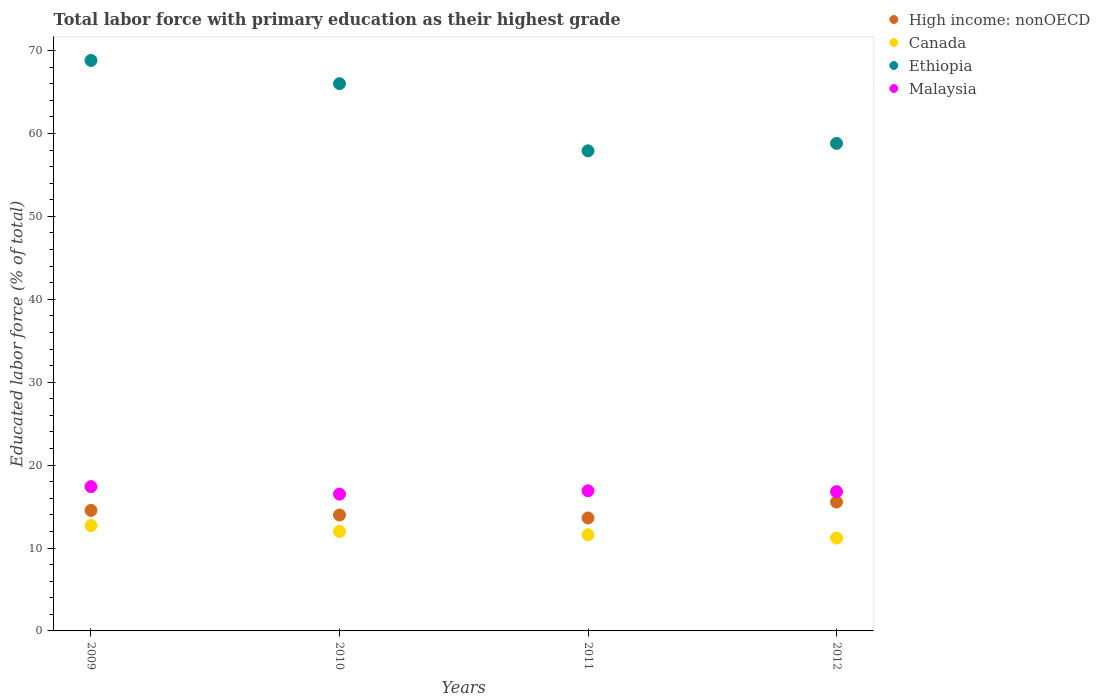How many different coloured dotlines are there?
Offer a terse response. 4. What is the percentage of total labor force with primary education in Ethiopia in 2009?
Your answer should be compact. 68.8. Across all years, what is the maximum percentage of total labor force with primary education in High income: nonOECD?
Provide a short and direct response. 15.55. What is the total percentage of total labor force with primary education in Malaysia in the graph?
Ensure brevity in your answer.  67.6. What is the difference between the percentage of total labor force with primary education in High income: nonOECD in 2009 and that in 2011?
Offer a terse response. 0.91. What is the difference between the percentage of total labor force with primary education in Malaysia in 2012 and the percentage of total labor force with primary education in Canada in 2010?
Make the answer very short. 4.8. What is the average percentage of total labor force with primary education in High income: nonOECD per year?
Offer a terse response. 14.42. In the year 2012, what is the difference between the percentage of total labor force with primary education in Malaysia and percentage of total labor force with primary education in Canada?
Make the answer very short. 5.6. In how many years, is the percentage of total labor force with primary education in Malaysia greater than 36 %?
Your response must be concise. 0. What is the ratio of the percentage of total labor force with primary education in Canada in 2009 to that in 2011?
Make the answer very short. 1.09. Is the percentage of total labor force with primary education in High income: nonOECD in 2009 less than that in 2012?
Your answer should be very brief. Yes. Is the difference between the percentage of total labor force with primary education in Malaysia in 2009 and 2011 greater than the difference between the percentage of total labor force with primary education in Canada in 2009 and 2011?
Keep it short and to the point. No. What is the difference between the highest and the second highest percentage of total labor force with primary education in Ethiopia?
Offer a terse response. 2.8. What is the difference between the highest and the lowest percentage of total labor force with primary education in Malaysia?
Offer a terse response. 0.9. Is the sum of the percentage of total labor force with primary education in Malaysia in 2011 and 2012 greater than the maximum percentage of total labor force with primary education in Canada across all years?
Provide a short and direct response. Yes. Is it the case that in every year, the sum of the percentage of total labor force with primary education in Malaysia and percentage of total labor force with primary education in Canada  is greater than the sum of percentage of total labor force with primary education in High income: nonOECD and percentage of total labor force with primary education in Ethiopia?
Make the answer very short. Yes. Is it the case that in every year, the sum of the percentage of total labor force with primary education in Canada and percentage of total labor force with primary education in Ethiopia  is greater than the percentage of total labor force with primary education in High income: nonOECD?
Keep it short and to the point. Yes. Does the percentage of total labor force with primary education in Canada monotonically increase over the years?
Provide a short and direct response. No. Is the percentage of total labor force with primary education in Canada strictly greater than the percentage of total labor force with primary education in High income: nonOECD over the years?
Make the answer very short. No. How many years are there in the graph?
Provide a succinct answer. 4. What is the difference between two consecutive major ticks on the Y-axis?
Offer a terse response. 10. Are the values on the major ticks of Y-axis written in scientific E-notation?
Offer a very short reply. No. Does the graph contain any zero values?
Give a very brief answer. No. Does the graph contain grids?
Your answer should be very brief. No. Where does the legend appear in the graph?
Provide a succinct answer. Top right. How many legend labels are there?
Provide a succinct answer. 4. How are the legend labels stacked?
Ensure brevity in your answer.  Vertical. What is the title of the graph?
Provide a short and direct response. Total labor force with primary education as their highest grade. What is the label or title of the X-axis?
Provide a succinct answer. Years. What is the label or title of the Y-axis?
Provide a succinct answer. Educated labor force (% of total). What is the Educated labor force (% of total) in High income: nonOECD in 2009?
Provide a short and direct response. 14.54. What is the Educated labor force (% of total) in Canada in 2009?
Offer a terse response. 12.7. What is the Educated labor force (% of total) of Ethiopia in 2009?
Your response must be concise. 68.8. What is the Educated labor force (% of total) in Malaysia in 2009?
Provide a short and direct response. 17.4. What is the Educated labor force (% of total) of High income: nonOECD in 2010?
Provide a short and direct response. 13.98. What is the Educated labor force (% of total) in Malaysia in 2010?
Your answer should be compact. 16.5. What is the Educated labor force (% of total) in High income: nonOECD in 2011?
Ensure brevity in your answer.  13.62. What is the Educated labor force (% of total) of Canada in 2011?
Your answer should be very brief. 11.6. What is the Educated labor force (% of total) of Ethiopia in 2011?
Your answer should be very brief. 57.9. What is the Educated labor force (% of total) in Malaysia in 2011?
Provide a succinct answer. 16.9. What is the Educated labor force (% of total) in High income: nonOECD in 2012?
Provide a succinct answer. 15.55. What is the Educated labor force (% of total) in Canada in 2012?
Provide a short and direct response. 11.2. What is the Educated labor force (% of total) of Ethiopia in 2012?
Offer a very short reply. 58.8. What is the Educated labor force (% of total) in Malaysia in 2012?
Your answer should be compact. 16.8. Across all years, what is the maximum Educated labor force (% of total) of High income: nonOECD?
Provide a succinct answer. 15.55. Across all years, what is the maximum Educated labor force (% of total) of Canada?
Keep it short and to the point. 12.7. Across all years, what is the maximum Educated labor force (% of total) in Ethiopia?
Offer a terse response. 68.8. Across all years, what is the maximum Educated labor force (% of total) of Malaysia?
Provide a succinct answer. 17.4. Across all years, what is the minimum Educated labor force (% of total) of High income: nonOECD?
Your answer should be compact. 13.62. Across all years, what is the minimum Educated labor force (% of total) in Canada?
Provide a short and direct response. 11.2. Across all years, what is the minimum Educated labor force (% of total) in Ethiopia?
Your answer should be very brief. 57.9. Across all years, what is the minimum Educated labor force (% of total) of Malaysia?
Offer a very short reply. 16.5. What is the total Educated labor force (% of total) of High income: nonOECD in the graph?
Offer a terse response. 57.68. What is the total Educated labor force (% of total) in Canada in the graph?
Provide a succinct answer. 47.5. What is the total Educated labor force (% of total) in Ethiopia in the graph?
Give a very brief answer. 251.5. What is the total Educated labor force (% of total) of Malaysia in the graph?
Offer a very short reply. 67.6. What is the difference between the Educated labor force (% of total) in High income: nonOECD in 2009 and that in 2010?
Your response must be concise. 0.56. What is the difference between the Educated labor force (% of total) in Canada in 2009 and that in 2010?
Provide a succinct answer. 0.7. What is the difference between the Educated labor force (% of total) in Malaysia in 2009 and that in 2010?
Offer a terse response. 0.9. What is the difference between the Educated labor force (% of total) in High income: nonOECD in 2009 and that in 2011?
Give a very brief answer. 0.91. What is the difference between the Educated labor force (% of total) in High income: nonOECD in 2009 and that in 2012?
Keep it short and to the point. -1.01. What is the difference between the Educated labor force (% of total) in Canada in 2009 and that in 2012?
Your answer should be compact. 1.5. What is the difference between the Educated labor force (% of total) in Ethiopia in 2009 and that in 2012?
Offer a very short reply. 10. What is the difference between the Educated labor force (% of total) in Malaysia in 2009 and that in 2012?
Give a very brief answer. 0.6. What is the difference between the Educated labor force (% of total) of High income: nonOECD in 2010 and that in 2011?
Give a very brief answer. 0.35. What is the difference between the Educated labor force (% of total) in Canada in 2010 and that in 2011?
Make the answer very short. 0.4. What is the difference between the Educated labor force (% of total) of Malaysia in 2010 and that in 2011?
Your answer should be compact. -0.4. What is the difference between the Educated labor force (% of total) of High income: nonOECD in 2010 and that in 2012?
Keep it short and to the point. -1.57. What is the difference between the Educated labor force (% of total) in Canada in 2010 and that in 2012?
Offer a very short reply. 0.8. What is the difference between the Educated labor force (% of total) in Malaysia in 2010 and that in 2012?
Give a very brief answer. -0.3. What is the difference between the Educated labor force (% of total) in High income: nonOECD in 2011 and that in 2012?
Your answer should be compact. -1.92. What is the difference between the Educated labor force (% of total) of High income: nonOECD in 2009 and the Educated labor force (% of total) of Canada in 2010?
Give a very brief answer. 2.54. What is the difference between the Educated labor force (% of total) of High income: nonOECD in 2009 and the Educated labor force (% of total) of Ethiopia in 2010?
Your answer should be compact. -51.46. What is the difference between the Educated labor force (% of total) of High income: nonOECD in 2009 and the Educated labor force (% of total) of Malaysia in 2010?
Provide a succinct answer. -1.96. What is the difference between the Educated labor force (% of total) in Canada in 2009 and the Educated labor force (% of total) in Ethiopia in 2010?
Your response must be concise. -53.3. What is the difference between the Educated labor force (% of total) of Ethiopia in 2009 and the Educated labor force (% of total) of Malaysia in 2010?
Keep it short and to the point. 52.3. What is the difference between the Educated labor force (% of total) of High income: nonOECD in 2009 and the Educated labor force (% of total) of Canada in 2011?
Offer a very short reply. 2.94. What is the difference between the Educated labor force (% of total) of High income: nonOECD in 2009 and the Educated labor force (% of total) of Ethiopia in 2011?
Provide a short and direct response. -43.36. What is the difference between the Educated labor force (% of total) in High income: nonOECD in 2009 and the Educated labor force (% of total) in Malaysia in 2011?
Provide a succinct answer. -2.36. What is the difference between the Educated labor force (% of total) in Canada in 2009 and the Educated labor force (% of total) in Ethiopia in 2011?
Keep it short and to the point. -45.2. What is the difference between the Educated labor force (% of total) of Ethiopia in 2009 and the Educated labor force (% of total) of Malaysia in 2011?
Your answer should be very brief. 51.9. What is the difference between the Educated labor force (% of total) of High income: nonOECD in 2009 and the Educated labor force (% of total) of Canada in 2012?
Keep it short and to the point. 3.34. What is the difference between the Educated labor force (% of total) of High income: nonOECD in 2009 and the Educated labor force (% of total) of Ethiopia in 2012?
Your answer should be compact. -44.26. What is the difference between the Educated labor force (% of total) in High income: nonOECD in 2009 and the Educated labor force (% of total) in Malaysia in 2012?
Ensure brevity in your answer.  -2.26. What is the difference between the Educated labor force (% of total) in Canada in 2009 and the Educated labor force (% of total) in Ethiopia in 2012?
Give a very brief answer. -46.1. What is the difference between the Educated labor force (% of total) in High income: nonOECD in 2010 and the Educated labor force (% of total) in Canada in 2011?
Your response must be concise. 2.38. What is the difference between the Educated labor force (% of total) of High income: nonOECD in 2010 and the Educated labor force (% of total) of Ethiopia in 2011?
Your answer should be very brief. -43.92. What is the difference between the Educated labor force (% of total) of High income: nonOECD in 2010 and the Educated labor force (% of total) of Malaysia in 2011?
Your response must be concise. -2.92. What is the difference between the Educated labor force (% of total) of Canada in 2010 and the Educated labor force (% of total) of Ethiopia in 2011?
Make the answer very short. -45.9. What is the difference between the Educated labor force (% of total) in Ethiopia in 2010 and the Educated labor force (% of total) in Malaysia in 2011?
Your answer should be compact. 49.1. What is the difference between the Educated labor force (% of total) of High income: nonOECD in 2010 and the Educated labor force (% of total) of Canada in 2012?
Ensure brevity in your answer.  2.78. What is the difference between the Educated labor force (% of total) of High income: nonOECD in 2010 and the Educated labor force (% of total) of Ethiopia in 2012?
Your response must be concise. -44.82. What is the difference between the Educated labor force (% of total) of High income: nonOECD in 2010 and the Educated labor force (% of total) of Malaysia in 2012?
Provide a succinct answer. -2.82. What is the difference between the Educated labor force (% of total) in Canada in 2010 and the Educated labor force (% of total) in Ethiopia in 2012?
Your answer should be very brief. -46.8. What is the difference between the Educated labor force (% of total) of Canada in 2010 and the Educated labor force (% of total) of Malaysia in 2012?
Provide a succinct answer. -4.8. What is the difference between the Educated labor force (% of total) in Ethiopia in 2010 and the Educated labor force (% of total) in Malaysia in 2012?
Your answer should be very brief. 49.2. What is the difference between the Educated labor force (% of total) in High income: nonOECD in 2011 and the Educated labor force (% of total) in Canada in 2012?
Keep it short and to the point. 2.42. What is the difference between the Educated labor force (% of total) of High income: nonOECD in 2011 and the Educated labor force (% of total) of Ethiopia in 2012?
Ensure brevity in your answer.  -45.18. What is the difference between the Educated labor force (% of total) of High income: nonOECD in 2011 and the Educated labor force (% of total) of Malaysia in 2012?
Keep it short and to the point. -3.18. What is the difference between the Educated labor force (% of total) in Canada in 2011 and the Educated labor force (% of total) in Ethiopia in 2012?
Your answer should be compact. -47.2. What is the difference between the Educated labor force (% of total) in Ethiopia in 2011 and the Educated labor force (% of total) in Malaysia in 2012?
Give a very brief answer. 41.1. What is the average Educated labor force (% of total) in High income: nonOECD per year?
Make the answer very short. 14.42. What is the average Educated labor force (% of total) in Canada per year?
Give a very brief answer. 11.88. What is the average Educated labor force (% of total) in Ethiopia per year?
Ensure brevity in your answer.  62.88. In the year 2009, what is the difference between the Educated labor force (% of total) of High income: nonOECD and Educated labor force (% of total) of Canada?
Provide a short and direct response. 1.84. In the year 2009, what is the difference between the Educated labor force (% of total) of High income: nonOECD and Educated labor force (% of total) of Ethiopia?
Offer a very short reply. -54.26. In the year 2009, what is the difference between the Educated labor force (% of total) of High income: nonOECD and Educated labor force (% of total) of Malaysia?
Offer a terse response. -2.86. In the year 2009, what is the difference between the Educated labor force (% of total) of Canada and Educated labor force (% of total) of Ethiopia?
Provide a succinct answer. -56.1. In the year 2009, what is the difference between the Educated labor force (% of total) in Canada and Educated labor force (% of total) in Malaysia?
Provide a succinct answer. -4.7. In the year 2009, what is the difference between the Educated labor force (% of total) in Ethiopia and Educated labor force (% of total) in Malaysia?
Make the answer very short. 51.4. In the year 2010, what is the difference between the Educated labor force (% of total) of High income: nonOECD and Educated labor force (% of total) of Canada?
Make the answer very short. 1.98. In the year 2010, what is the difference between the Educated labor force (% of total) of High income: nonOECD and Educated labor force (% of total) of Ethiopia?
Your answer should be compact. -52.02. In the year 2010, what is the difference between the Educated labor force (% of total) of High income: nonOECD and Educated labor force (% of total) of Malaysia?
Ensure brevity in your answer.  -2.52. In the year 2010, what is the difference between the Educated labor force (% of total) of Canada and Educated labor force (% of total) of Ethiopia?
Your answer should be compact. -54. In the year 2010, what is the difference between the Educated labor force (% of total) in Ethiopia and Educated labor force (% of total) in Malaysia?
Give a very brief answer. 49.5. In the year 2011, what is the difference between the Educated labor force (% of total) of High income: nonOECD and Educated labor force (% of total) of Canada?
Your answer should be very brief. 2.02. In the year 2011, what is the difference between the Educated labor force (% of total) of High income: nonOECD and Educated labor force (% of total) of Ethiopia?
Give a very brief answer. -44.28. In the year 2011, what is the difference between the Educated labor force (% of total) in High income: nonOECD and Educated labor force (% of total) in Malaysia?
Make the answer very short. -3.28. In the year 2011, what is the difference between the Educated labor force (% of total) in Canada and Educated labor force (% of total) in Ethiopia?
Provide a succinct answer. -46.3. In the year 2011, what is the difference between the Educated labor force (% of total) in Canada and Educated labor force (% of total) in Malaysia?
Your answer should be compact. -5.3. In the year 2012, what is the difference between the Educated labor force (% of total) in High income: nonOECD and Educated labor force (% of total) in Canada?
Your response must be concise. 4.35. In the year 2012, what is the difference between the Educated labor force (% of total) in High income: nonOECD and Educated labor force (% of total) in Ethiopia?
Provide a short and direct response. -43.25. In the year 2012, what is the difference between the Educated labor force (% of total) of High income: nonOECD and Educated labor force (% of total) of Malaysia?
Your answer should be very brief. -1.25. In the year 2012, what is the difference between the Educated labor force (% of total) of Canada and Educated labor force (% of total) of Ethiopia?
Make the answer very short. -47.6. In the year 2012, what is the difference between the Educated labor force (% of total) in Canada and Educated labor force (% of total) in Malaysia?
Offer a very short reply. -5.6. What is the ratio of the Educated labor force (% of total) in High income: nonOECD in 2009 to that in 2010?
Offer a terse response. 1.04. What is the ratio of the Educated labor force (% of total) in Canada in 2009 to that in 2010?
Provide a short and direct response. 1.06. What is the ratio of the Educated labor force (% of total) of Ethiopia in 2009 to that in 2010?
Offer a terse response. 1.04. What is the ratio of the Educated labor force (% of total) of Malaysia in 2009 to that in 2010?
Keep it short and to the point. 1.05. What is the ratio of the Educated labor force (% of total) of High income: nonOECD in 2009 to that in 2011?
Make the answer very short. 1.07. What is the ratio of the Educated labor force (% of total) in Canada in 2009 to that in 2011?
Ensure brevity in your answer.  1.09. What is the ratio of the Educated labor force (% of total) in Ethiopia in 2009 to that in 2011?
Give a very brief answer. 1.19. What is the ratio of the Educated labor force (% of total) in Malaysia in 2009 to that in 2011?
Make the answer very short. 1.03. What is the ratio of the Educated labor force (% of total) in High income: nonOECD in 2009 to that in 2012?
Offer a terse response. 0.94. What is the ratio of the Educated labor force (% of total) of Canada in 2009 to that in 2012?
Keep it short and to the point. 1.13. What is the ratio of the Educated labor force (% of total) in Ethiopia in 2009 to that in 2012?
Your answer should be very brief. 1.17. What is the ratio of the Educated labor force (% of total) of Malaysia in 2009 to that in 2012?
Offer a terse response. 1.04. What is the ratio of the Educated labor force (% of total) in High income: nonOECD in 2010 to that in 2011?
Offer a terse response. 1.03. What is the ratio of the Educated labor force (% of total) of Canada in 2010 to that in 2011?
Offer a terse response. 1.03. What is the ratio of the Educated labor force (% of total) in Ethiopia in 2010 to that in 2011?
Offer a very short reply. 1.14. What is the ratio of the Educated labor force (% of total) in Malaysia in 2010 to that in 2011?
Provide a short and direct response. 0.98. What is the ratio of the Educated labor force (% of total) in High income: nonOECD in 2010 to that in 2012?
Your response must be concise. 0.9. What is the ratio of the Educated labor force (% of total) of Canada in 2010 to that in 2012?
Make the answer very short. 1.07. What is the ratio of the Educated labor force (% of total) in Ethiopia in 2010 to that in 2012?
Your answer should be compact. 1.12. What is the ratio of the Educated labor force (% of total) in Malaysia in 2010 to that in 2012?
Provide a succinct answer. 0.98. What is the ratio of the Educated labor force (% of total) of High income: nonOECD in 2011 to that in 2012?
Your response must be concise. 0.88. What is the ratio of the Educated labor force (% of total) in Canada in 2011 to that in 2012?
Ensure brevity in your answer.  1.04. What is the ratio of the Educated labor force (% of total) in Ethiopia in 2011 to that in 2012?
Your answer should be very brief. 0.98. What is the difference between the highest and the second highest Educated labor force (% of total) in High income: nonOECD?
Keep it short and to the point. 1.01. What is the difference between the highest and the second highest Educated labor force (% of total) in Ethiopia?
Your answer should be compact. 2.8. What is the difference between the highest and the second highest Educated labor force (% of total) of Malaysia?
Your answer should be compact. 0.5. What is the difference between the highest and the lowest Educated labor force (% of total) in High income: nonOECD?
Your answer should be compact. 1.92. What is the difference between the highest and the lowest Educated labor force (% of total) of Ethiopia?
Your answer should be very brief. 10.9. What is the difference between the highest and the lowest Educated labor force (% of total) of Malaysia?
Your answer should be compact. 0.9. 